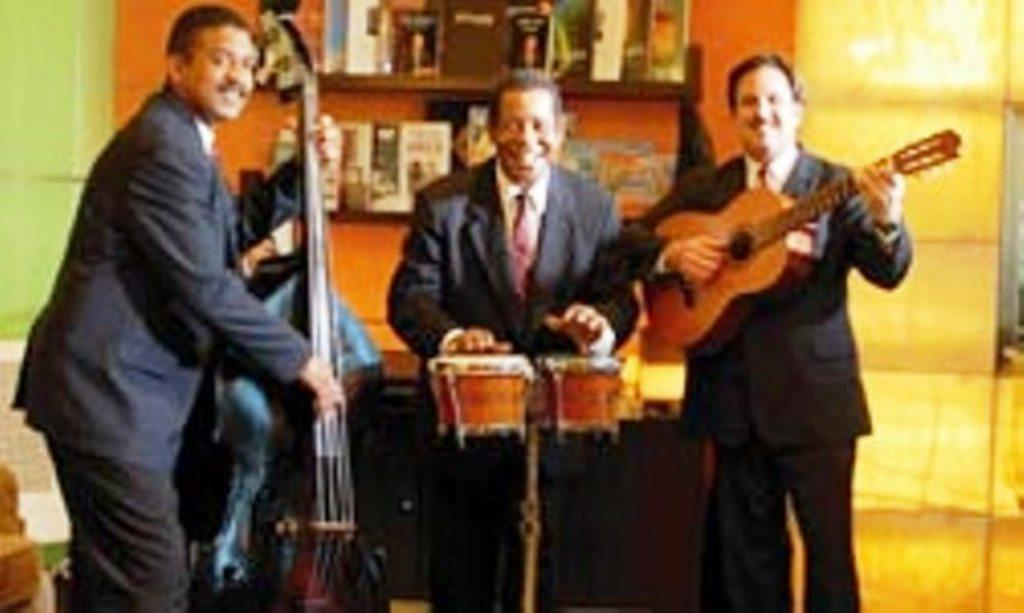How many people are in the image? There are three men in the image. What are the men holding in the image? Each of the men is holding a musical instrument. What type of clothing are the men wearing on their upper bodies? The men are wearing blazers. What type of clothing are the men wearing around their necks? The men are wearing ties. What type of shoes are the men wearing in the image? The provided facts do not mention any shoes, so we cannot determine the type of shoes the men are wearing. 